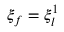<formula> <loc_0><loc_0><loc_500><loc_500>\xi _ { f } = \xi _ { l } ^ { 1 }</formula> 